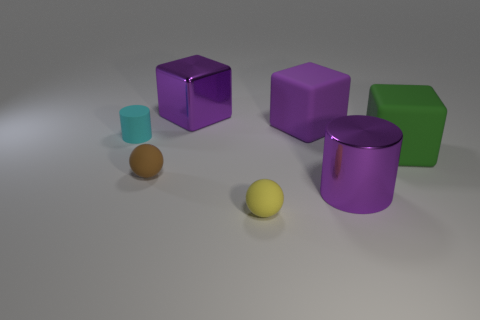There is another object that is the same shape as the small cyan matte object; what is its size?
Your answer should be very brief. Large. There is another large cube that is the same color as the metal block; what is it made of?
Offer a terse response. Rubber. There is a yellow rubber thing that is the same size as the brown object; what is its shape?
Ensure brevity in your answer.  Sphere. Is there a big yellow metallic thing that has the same shape as the brown rubber object?
Your response must be concise. No. The large matte thing on the left side of the cylinder that is in front of the small matte cylinder is what shape?
Provide a short and direct response. Cube. The brown thing is what shape?
Offer a very short reply. Sphere. The tiny sphere that is right of the large thing left of the small object that is right of the shiny block is made of what material?
Make the answer very short. Rubber. What number of other things are there of the same material as the big purple cylinder
Your response must be concise. 1. What number of yellow balls are left of the metallic thing that is in front of the tiny brown object?
Offer a terse response. 1. What number of blocks are big green matte things or yellow rubber objects?
Offer a terse response. 1. 